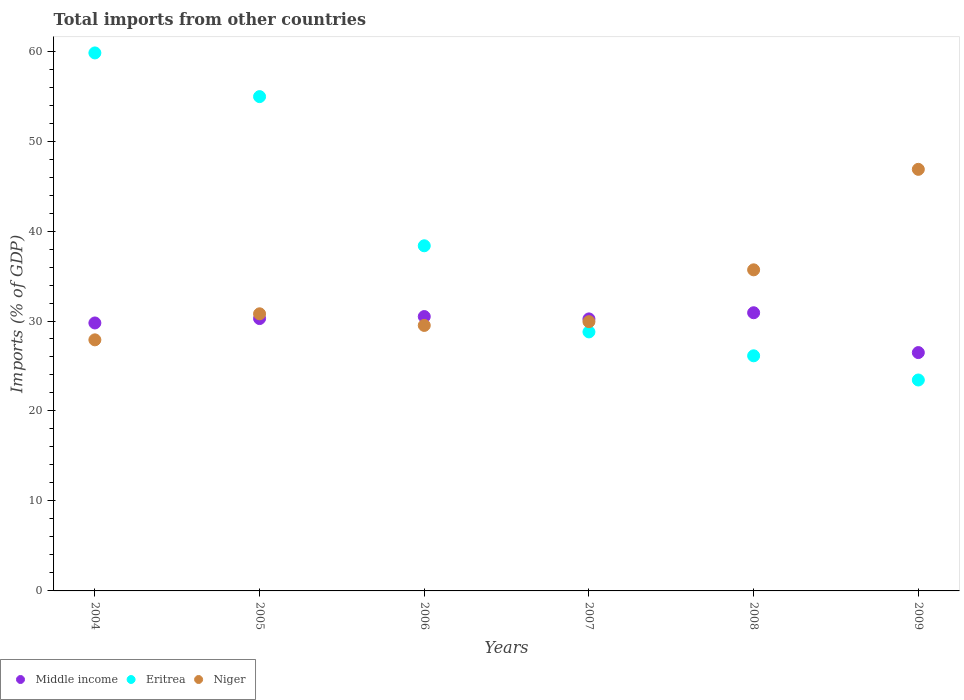How many different coloured dotlines are there?
Give a very brief answer. 3. Is the number of dotlines equal to the number of legend labels?
Make the answer very short. Yes. What is the total imports in Middle income in 2005?
Keep it short and to the point. 30.27. Across all years, what is the maximum total imports in Eritrea?
Your response must be concise. 59.8. Across all years, what is the minimum total imports in Middle income?
Keep it short and to the point. 26.49. In which year was the total imports in Middle income maximum?
Provide a short and direct response. 2008. What is the total total imports in Eritrea in the graph?
Provide a short and direct response. 231.46. What is the difference between the total imports in Eritrea in 2004 and that in 2006?
Ensure brevity in your answer.  21.43. What is the difference between the total imports in Niger in 2008 and the total imports in Middle income in 2009?
Give a very brief answer. 9.2. What is the average total imports in Niger per year?
Provide a succinct answer. 33.45. In the year 2007, what is the difference between the total imports in Eritrea and total imports in Niger?
Your answer should be compact. -1.14. What is the ratio of the total imports in Eritrea in 2004 to that in 2007?
Your answer should be very brief. 2.08. Is the total imports in Eritrea in 2004 less than that in 2005?
Give a very brief answer. No. Is the difference between the total imports in Eritrea in 2005 and 2007 greater than the difference between the total imports in Niger in 2005 and 2007?
Your answer should be compact. Yes. What is the difference between the highest and the second highest total imports in Niger?
Make the answer very short. 11.17. What is the difference between the highest and the lowest total imports in Middle income?
Ensure brevity in your answer.  4.43. Is the sum of the total imports in Eritrea in 2004 and 2009 greater than the maximum total imports in Niger across all years?
Ensure brevity in your answer.  Yes. Is the total imports in Middle income strictly greater than the total imports in Eritrea over the years?
Your answer should be compact. No. How many years are there in the graph?
Your answer should be compact. 6. Are the values on the major ticks of Y-axis written in scientific E-notation?
Your response must be concise. No. Does the graph contain grids?
Provide a succinct answer. No. How many legend labels are there?
Your answer should be compact. 3. What is the title of the graph?
Offer a terse response. Total imports from other countries. What is the label or title of the Y-axis?
Keep it short and to the point. Imports (% of GDP). What is the Imports (% of GDP) of Middle income in 2004?
Give a very brief answer. 29.78. What is the Imports (% of GDP) of Eritrea in 2004?
Offer a very short reply. 59.8. What is the Imports (% of GDP) of Niger in 2004?
Make the answer very short. 27.91. What is the Imports (% of GDP) of Middle income in 2005?
Make the answer very short. 30.27. What is the Imports (% of GDP) in Eritrea in 2005?
Give a very brief answer. 54.94. What is the Imports (% of GDP) in Niger in 2005?
Keep it short and to the point. 30.8. What is the Imports (% of GDP) in Middle income in 2006?
Provide a short and direct response. 30.49. What is the Imports (% of GDP) in Eritrea in 2006?
Provide a short and direct response. 38.36. What is the Imports (% of GDP) in Niger in 2006?
Give a very brief answer. 29.51. What is the Imports (% of GDP) in Middle income in 2007?
Provide a succinct answer. 30.23. What is the Imports (% of GDP) of Eritrea in 2007?
Your answer should be compact. 28.79. What is the Imports (% of GDP) in Niger in 2007?
Keep it short and to the point. 29.93. What is the Imports (% of GDP) of Middle income in 2008?
Keep it short and to the point. 30.92. What is the Imports (% of GDP) of Eritrea in 2008?
Your response must be concise. 26.13. What is the Imports (% of GDP) in Niger in 2008?
Your response must be concise. 35.69. What is the Imports (% of GDP) in Middle income in 2009?
Make the answer very short. 26.49. What is the Imports (% of GDP) of Eritrea in 2009?
Keep it short and to the point. 23.44. What is the Imports (% of GDP) in Niger in 2009?
Your response must be concise. 46.86. Across all years, what is the maximum Imports (% of GDP) in Middle income?
Provide a short and direct response. 30.92. Across all years, what is the maximum Imports (% of GDP) in Eritrea?
Offer a terse response. 59.8. Across all years, what is the maximum Imports (% of GDP) of Niger?
Provide a short and direct response. 46.86. Across all years, what is the minimum Imports (% of GDP) of Middle income?
Provide a succinct answer. 26.49. Across all years, what is the minimum Imports (% of GDP) of Eritrea?
Provide a short and direct response. 23.44. Across all years, what is the minimum Imports (% of GDP) in Niger?
Keep it short and to the point. 27.91. What is the total Imports (% of GDP) of Middle income in the graph?
Offer a terse response. 178.19. What is the total Imports (% of GDP) of Eritrea in the graph?
Keep it short and to the point. 231.46. What is the total Imports (% of GDP) in Niger in the graph?
Make the answer very short. 200.69. What is the difference between the Imports (% of GDP) in Middle income in 2004 and that in 2005?
Your answer should be compact. -0.49. What is the difference between the Imports (% of GDP) of Eritrea in 2004 and that in 2005?
Offer a terse response. 4.86. What is the difference between the Imports (% of GDP) of Niger in 2004 and that in 2005?
Keep it short and to the point. -2.89. What is the difference between the Imports (% of GDP) of Middle income in 2004 and that in 2006?
Ensure brevity in your answer.  -0.71. What is the difference between the Imports (% of GDP) in Eritrea in 2004 and that in 2006?
Make the answer very short. 21.43. What is the difference between the Imports (% of GDP) of Niger in 2004 and that in 2006?
Your answer should be very brief. -1.6. What is the difference between the Imports (% of GDP) in Middle income in 2004 and that in 2007?
Your answer should be very brief. -0.45. What is the difference between the Imports (% of GDP) of Eritrea in 2004 and that in 2007?
Keep it short and to the point. 31.01. What is the difference between the Imports (% of GDP) in Niger in 2004 and that in 2007?
Provide a succinct answer. -2.02. What is the difference between the Imports (% of GDP) of Middle income in 2004 and that in 2008?
Offer a very short reply. -1.14. What is the difference between the Imports (% of GDP) of Eritrea in 2004 and that in 2008?
Keep it short and to the point. 33.66. What is the difference between the Imports (% of GDP) in Niger in 2004 and that in 2008?
Provide a short and direct response. -7.78. What is the difference between the Imports (% of GDP) of Middle income in 2004 and that in 2009?
Offer a very short reply. 3.29. What is the difference between the Imports (% of GDP) in Eritrea in 2004 and that in 2009?
Provide a short and direct response. 36.35. What is the difference between the Imports (% of GDP) in Niger in 2004 and that in 2009?
Keep it short and to the point. -18.95. What is the difference between the Imports (% of GDP) of Middle income in 2005 and that in 2006?
Make the answer very short. -0.22. What is the difference between the Imports (% of GDP) in Eritrea in 2005 and that in 2006?
Your response must be concise. 16.58. What is the difference between the Imports (% of GDP) in Niger in 2005 and that in 2006?
Your answer should be compact. 1.29. What is the difference between the Imports (% of GDP) in Middle income in 2005 and that in 2007?
Provide a succinct answer. 0.04. What is the difference between the Imports (% of GDP) in Eritrea in 2005 and that in 2007?
Your answer should be compact. 26.15. What is the difference between the Imports (% of GDP) of Niger in 2005 and that in 2007?
Provide a succinct answer. 0.87. What is the difference between the Imports (% of GDP) of Middle income in 2005 and that in 2008?
Provide a short and direct response. -0.65. What is the difference between the Imports (% of GDP) of Eritrea in 2005 and that in 2008?
Offer a very short reply. 28.81. What is the difference between the Imports (% of GDP) of Niger in 2005 and that in 2008?
Keep it short and to the point. -4.89. What is the difference between the Imports (% of GDP) in Middle income in 2005 and that in 2009?
Your answer should be compact. 3.78. What is the difference between the Imports (% of GDP) in Eritrea in 2005 and that in 2009?
Keep it short and to the point. 31.5. What is the difference between the Imports (% of GDP) in Niger in 2005 and that in 2009?
Provide a succinct answer. -16.06. What is the difference between the Imports (% of GDP) of Middle income in 2006 and that in 2007?
Your answer should be very brief. 0.26. What is the difference between the Imports (% of GDP) of Eritrea in 2006 and that in 2007?
Provide a succinct answer. 9.57. What is the difference between the Imports (% of GDP) in Niger in 2006 and that in 2007?
Ensure brevity in your answer.  -0.42. What is the difference between the Imports (% of GDP) of Middle income in 2006 and that in 2008?
Provide a short and direct response. -0.42. What is the difference between the Imports (% of GDP) of Eritrea in 2006 and that in 2008?
Offer a terse response. 12.23. What is the difference between the Imports (% of GDP) of Niger in 2006 and that in 2008?
Offer a very short reply. -6.18. What is the difference between the Imports (% of GDP) of Middle income in 2006 and that in 2009?
Offer a very short reply. 4. What is the difference between the Imports (% of GDP) in Eritrea in 2006 and that in 2009?
Your answer should be very brief. 14.92. What is the difference between the Imports (% of GDP) of Niger in 2006 and that in 2009?
Your answer should be compact. -17.35. What is the difference between the Imports (% of GDP) in Middle income in 2007 and that in 2008?
Your response must be concise. -0.68. What is the difference between the Imports (% of GDP) of Eritrea in 2007 and that in 2008?
Provide a succinct answer. 2.66. What is the difference between the Imports (% of GDP) in Niger in 2007 and that in 2008?
Make the answer very short. -5.76. What is the difference between the Imports (% of GDP) of Middle income in 2007 and that in 2009?
Your answer should be very brief. 3.74. What is the difference between the Imports (% of GDP) of Eritrea in 2007 and that in 2009?
Ensure brevity in your answer.  5.34. What is the difference between the Imports (% of GDP) of Niger in 2007 and that in 2009?
Ensure brevity in your answer.  -16.93. What is the difference between the Imports (% of GDP) of Middle income in 2008 and that in 2009?
Keep it short and to the point. 4.43. What is the difference between the Imports (% of GDP) of Eritrea in 2008 and that in 2009?
Provide a short and direct response. 2.69. What is the difference between the Imports (% of GDP) of Niger in 2008 and that in 2009?
Keep it short and to the point. -11.17. What is the difference between the Imports (% of GDP) in Middle income in 2004 and the Imports (% of GDP) in Eritrea in 2005?
Give a very brief answer. -25.16. What is the difference between the Imports (% of GDP) in Middle income in 2004 and the Imports (% of GDP) in Niger in 2005?
Keep it short and to the point. -1.02. What is the difference between the Imports (% of GDP) of Eritrea in 2004 and the Imports (% of GDP) of Niger in 2005?
Make the answer very short. 29. What is the difference between the Imports (% of GDP) of Middle income in 2004 and the Imports (% of GDP) of Eritrea in 2006?
Offer a terse response. -8.58. What is the difference between the Imports (% of GDP) of Middle income in 2004 and the Imports (% of GDP) of Niger in 2006?
Keep it short and to the point. 0.27. What is the difference between the Imports (% of GDP) in Eritrea in 2004 and the Imports (% of GDP) in Niger in 2006?
Keep it short and to the point. 30.29. What is the difference between the Imports (% of GDP) in Middle income in 2004 and the Imports (% of GDP) in Eritrea in 2007?
Your answer should be compact. 0.99. What is the difference between the Imports (% of GDP) in Middle income in 2004 and the Imports (% of GDP) in Niger in 2007?
Your answer should be compact. -0.14. What is the difference between the Imports (% of GDP) in Eritrea in 2004 and the Imports (% of GDP) in Niger in 2007?
Your response must be concise. 29.87. What is the difference between the Imports (% of GDP) of Middle income in 2004 and the Imports (% of GDP) of Eritrea in 2008?
Your answer should be very brief. 3.65. What is the difference between the Imports (% of GDP) in Middle income in 2004 and the Imports (% of GDP) in Niger in 2008?
Ensure brevity in your answer.  -5.91. What is the difference between the Imports (% of GDP) in Eritrea in 2004 and the Imports (% of GDP) in Niger in 2008?
Provide a short and direct response. 24.11. What is the difference between the Imports (% of GDP) in Middle income in 2004 and the Imports (% of GDP) in Eritrea in 2009?
Your response must be concise. 6.34. What is the difference between the Imports (% of GDP) of Middle income in 2004 and the Imports (% of GDP) of Niger in 2009?
Make the answer very short. -17.07. What is the difference between the Imports (% of GDP) in Eritrea in 2004 and the Imports (% of GDP) in Niger in 2009?
Ensure brevity in your answer.  12.94. What is the difference between the Imports (% of GDP) in Middle income in 2005 and the Imports (% of GDP) in Eritrea in 2006?
Ensure brevity in your answer.  -8.09. What is the difference between the Imports (% of GDP) in Middle income in 2005 and the Imports (% of GDP) in Niger in 2006?
Your answer should be very brief. 0.76. What is the difference between the Imports (% of GDP) in Eritrea in 2005 and the Imports (% of GDP) in Niger in 2006?
Offer a very short reply. 25.43. What is the difference between the Imports (% of GDP) of Middle income in 2005 and the Imports (% of GDP) of Eritrea in 2007?
Provide a succinct answer. 1.48. What is the difference between the Imports (% of GDP) in Middle income in 2005 and the Imports (% of GDP) in Niger in 2007?
Your answer should be very brief. 0.34. What is the difference between the Imports (% of GDP) in Eritrea in 2005 and the Imports (% of GDP) in Niger in 2007?
Your answer should be compact. 25.01. What is the difference between the Imports (% of GDP) in Middle income in 2005 and the Imports (% of GDP) in Eritrea in 2008?
Offer a very short reply. 4.14. What is the difference between the Imports (% of GDP) in Middle income in 2005 and the Imports (% of GDP) in Niger in 2008?
Provide a succinct answer. -5.42. What is the difference between the Imports (% of GDP) in Eritrea in 2005 and the Imports (% of GDP) in Niger in 2008?
Provide a succinct answer. 19.25. What is the difference between the Imports (% of GDP) of Middle income in 2005 and the Imports (% of GDP) of Eritrea in 2009?
Offer a terse response. 6.83. What is the difference between the Imports (% of GDP) in Middle income in 2005 and the Imports (% of GDP) in Niger in 2009?
Ensure brevity in your answer.  -16.59. What is the difference between the Imports (% of GDP) of Eritrea in 2005 and the Imports (% of GDP) of Niger in 2009?
Offer a terse response. 8.08. What is the difference between the Imports (% of GDP) of Middle income in 2006 and the Imports (% of GDP) of Eritrea in 2007?
Give a very brief answer. 1.71. What is the difference between the Imports (% of GDP) in Middle income in 2006 and the Imports (% of GDP) in Niger in 2007?
Keep it short and to the point. 0.57. What is the difference between the Imports (% of GDP) of Eritrea in 2006 and the Imports (% of GDP) of Niger in 2007?
Offer a very short reply. 8.44. What is the difference between the Imports (% of GDP) in Middle income in 2006 and the Imports (% of GDP) in Eritrea in 2008?
Offer a terse response. 4.36. What is the difference between the Imports (% of GDP) of Middle income in 2006 and the Imports (% of GDP) of Niger in 2008?
Provide a succinct answer. -5.19. What is the difference between the Imports (% of GDP) of Eritrea in 2006 and the Imports (% of GDP) of Niger in 2008?
Give a very brief answer. 2.67. What is the difference between the Imports (% of GDP) of Middle income in 2006 and the Imports (% of GDP) of Eritrea in 2009?
Keep it short and to the point. 7.05. What is the difference between the Imports (% of GDP) in Middle income in 2006 and the Imports (% of GDP) in Niger in 2009?
Keep it short and to the point. -16.36. What is the difference between the Imports (% of GDP) of Eritrea in 2006 and the Imports (% of GDP) of Niger in 2009?
Make the answer very short. -8.5. What is the difference between the Imports (% of GDP) of Middle income in 2007 and the Imports (% of GDP) of Eritrea in 2008?
Make the answer very short. 4.1. What is the difference between the Imports (% of GDP) of Middle income in 2007 and the Imports (% of GDP) of Niger in 2008?
Make the answer very short. -5.45. What is the difference between the Imports (% of GDP) of Eritrea in 2007 and the Imports (% of GDP) of Niger in 2008?
Your response must be concise. -6.9. What is the difference between the Imports (% of GDP) in Middle income in 2007 and the Imports (% of GDP) in Eritrea in 2009?
Your answer should be compact. 6.79. What is the difference between the Imports (% of GDP) of Middle income in 2007 and the Imports (% of GDP) of Niger in 2009?
Make the answer very short. -16.62. What is the difference between the Imports (% of GDP) of Eritrea in 2007 and the Imports (% of GDP) of Niger in 2009?
Your answer should be very brief. -18.07. What is the difference between the Imports (% of GDP) in Middle income in 2008 and the Imports (% of GDP) in Eritrea in 2009?
Keep it short and to the point. 7.47. What is the difference between the Imports (% of GDP) of Middle income in 2008 and the Imports (% of GDP) of Niger in 2009?
Make the answer very short. -15.94. What is the difference between the Imports (% of GDP) of Eritrea in 2008 and the Imports (% of GDP) of Niger in 2009?
Ensure brevity in your answer.  -20.72. What is the average Imports (% of GDP) in Middle income per year?
Make the answer very short. 29.7. What is the average Imports (% of GDP) in Eritrea per year?
Provide a short and direct response. 38.58. What is the average Imports (% of GDP) in Niger per year?
Your answer should be very brief. 33.45. In the year 2004, what is the difference between the Imports (% of GDP) in Middle income and Imports (% of GDP) in Eritrea?
Make the answer very short. -30.01. In the year 2004, what is the difference between the Imports (% of GDP) of Middle income and Imports (% of GDP) of Niger?
Ensure brevity in your answer.  1.88. In the year 2004, what is the difference between the Imports (% of GDP) of Eritrea and Imports (% of GDP) of Niger?
Give a very brief answer. 31.89. In the year 2005, what is the difference between the Imports (% of GDP) in Middle income and Imports (% of GDP) in Eritrea?
Provide a succinct answer. -24.67. In the year 2005, what is the difference between the Imports (% of GDP) of Middle income and Imports (% of GDP) of Niger?
Ensure brevity in your answer.  -0.53. In the year 2005, what is the difference between the Imports (% of GDP) of Eritrea and Imports (% of GDP) of Niger?
Offer a very short reply. 24.14. In the year 2006, what is the difference between the Imports (% of GDP) in Middle income and Imports (% of GDP) in Eritrea?
Your response must be concise. -7.87. In the year 2006, what is the difference between the Imports (% of GDP) in Middle income and Imports (% of GDP) in Niger?
Provide a succinct answer. 0.98. In the year 2006, what is the difference between the Imports (% of GDP) of Eritrea and Imports (% of GDP) of Niger?
Your answer should be very brief. 8.85. In the year 2007, what is the difference between the Imports (% of GDP) in Middle income and Imports (% of GDP) in Eritrea?
Offer a terse response. 1.45. In the year 2007, what is the difference between the Imports (% of GDP) of Middle income and Imports (% of GDP) of Niger?
Offer a terse response. 0.31. In the year 2007, what is the difference between the Imports (% of GDP) of Eritrea and Imports (% of GDP) of Niger?
Make the answer very short. -1.14. In the year 2008, what is the difference between the Imports (% of GDP) in Middle income and Imports (% of GDP) in Eritrea?
Provide a succinct answer. 4.79. In the year 2008, what is the difference between the Imports (% of GDP) of Middle income and Imports (% of GDP) of Niger?
Provide a short and direct response. -4.77. In the year 2008, what is the difference between the Imports (% of GDP) of Eritrea and Imports (% of GDP) of Niger?
Offer a terse response. -9.56. In the year 2009, what is the difference between the Imports (% of GDP) of Middle income and Imports (% of GDP) of Eritrea?
Ensure brevity in your answer.  3.05. In the year 2009, what is the difference between the Imports (% of GDP) of Middle income and Imports (% of GDP) of Niger?
Give a very brief answer. -20.37. In the year 2009, what is the difference between the Imports (% of GDP) in Eritrea and Imports (% of GDP) in Niger?
Your response must be concise. -23.41. What is the ratio of the Imports (% of GDP) of Middle income in 2004 to that in 2005?
Provide a succinct answer. 0.98. What is the ratio of the Imports (% of GDP) of Eritrea in 2004 to that in 2005?
Offer a terse response. 1.09. What is the ratio of the Imports (% of GDP) in Niger in 2004 to that in 2005?
Provide a succinct answer. 0.91. What is the ratio of the Imports (% of GDP) in Middle income in 2004 to that in 2006?
Provide a succinct answer. 0.98. What is the ratio of the Imports (% of GDP) in Eritrea in 2004 to that in 2006?
Your response must be concise. 1.56. What is the ratio of the Imports (% of GDP) of Niger in 2004 to that in 2006?
Provide a succinct answer. 0.95. What is the ratio of the Imports (% of GDP) of Middle income in 2004 to that in 2007?
Your response must be concise. 0.99. What is the ratio of the Imports (% of GDP) in Eritrea in 2004 to that in 2007?
Offer a very short reply. 2.08. What is the ratio of the Imports (% of GDP) of Niger in 2004 to that in 2007?
Your answer should be very brief. 0.93. What is the ratio of the Imports (% of GDP) in Middle income in 2004 to that in 2008?
Offer a terse response. 0.96. What is the ratio of the Imports (% of GDP) of Eritrea in 2004 to that in 2008?
Keep it short and to the point. 2.29. What is the ratio of the Imports (% of GDP) in Niger in 2004 to that in 2008?
Ensure brevity in your answer.  0.78. What is the ratio of the Imports (% of GDP) of Middle income in 2004 to that in 2009?
Your answer should be compact. 1.12. What is the ratio of the Imports (% of GDP) of Eritrea in 2004 to that in 2009?
Offer a very short reply. 2.55. What is the ratio of the Imports (% of GDP) of Niger in 2004 to that in 2009?
Offer a very short reply. 0.6. What is the ratio of the Imports (% of GDP) in Middle income in 2005 to that in 2006?
Your answer should be very brief. 0.99. What is the ratio of the Imports (% of GDP) of Eritrea in 2005 to that in 2006?
Your response must be concise. 1.43. What is the ratio of the Imports (% of GDP) of Niger in 2005 to that in 2006?
Your response must be concise. 1.04. What is the ratio of the Imports (% of GDP) in Eritrea in 2005 to that in 2007?
Provide a short and direct response. 1.91. What is the ratio of the Imports (% of GDP) in Niger in 2005 to that in 2007?
Provide a short and direct response. 1.03. What is the ratio of the Imports (% of GDP) of Middle income in 2005 to that in 2008?
Your answer should be very brief. 0.98. What is the ratio of the Imports (% of GDP) of Eritrea in 2005 to that in 2008?
Make the answer very short. 2.1. What is the ratio of the Imports (% of GDP) in Niger in 2005 to that in 2008?
Provide a succinct answer. 0.86. What is the ratio of the Imports (% of GDP) in Middle income in 2005 to that in 2009?
Make the answer very short. 1.14. What is the ratio of the Imports (% of GDP) of Eritrea in 2005 to that in 2009?
Your answer should be compact. 2.34. What is the ratio of the Imports (% of GDP) in Niger in 2005 to that in 2009?
Offer a very short reply. 0.66. What is the ratio of the Imports (% of GDP) in Middle income in 2006 to that in 2007?
Provide a succinct answer. 1.01. What is the ratio of the Imports (% of GDP) in Eritrea in 2006 to that in 2007?
Make the answer very short. 1.33. What is the ratio of the Imports (% of GDP) of Niger in 2006 to that in 2007?
Give a very brief answer. 0.99. What is the ratio of the Imports (% of GDP) of Middle income in 2006 to that in 2008?
Provide a short and direct response. 0.99. What is the ratio of the Imports (% of GDP) of Eritrea in 2006 to that in 2008?
Make the answer very short. 1.47. What is the ratio of the Imports (% of GDP) of Niger in 2006 to that in 2008?
Give a very brief answer. 0.83. What is the ratio of the Imports (% of GDP) of Middle income in 2006 to that in 2009?
Your answer should be very brief. 1.15. What is the ratio of the Imports (% of GDP) of Eritrea in 2006 to that in 2009?
Ensure brevity in your answer.  1.64. What is the ratio of the Imports (% of GDP) in Niger in 2006 to that in 2009?
Make the answer very short. 0.63. What is the ratio of the Imports (% of GDP) of Middle income in 2007 to that in 2008?
Offer a terse response. 0.98. What is the ratio of the Imports (% of GDP) in Eritrea in 2007 to that in 2008?
Ensure brevity in your answer.  1.1. What is the ratio of the Imports (% of GDP) in Niger in 2007 to that in 2008?
Give a very brief answer. 0.84. What is the ratio of the Imports (% of GDP) of Middle income in 2007 to that in 2009?
Ensure brevity in your answer.  1.14. What is the ratio of the Imports (% of GDP) in Eritrea in 2007 to that in 2009?
Offer a terse response. 1.23. What is the ratio of the Imports (% of GDP) in Niger in 2007 to that in 2009?
Ensure brevity in your answer.  0.64. What is the ratio of the Imports (% of GDP) in Middle income in 2008 to that in 2009?
Your response must be concise. 1.17. What is the ratio of the Imports (% of GDP) of Eritrea in 2008 to that in 2009?
Your response must be concise. 1.11. What is the ratio of the Imports (% of GDP) in Niger in 2008 to that in 2009?
Provide a short and direct response. 0.76. What is the difference between the highest and the second highest Imports (% of GDP) in Middle income?
Provide a short and direct response. 0.42. What is the difference between the highest and the second highest Imports (% of GDP) in Eritrea?
Provide a short and direct response. 4.86. What is the difference between the highest and the second highest Imports (% of GDP) of Niger?
Make the answer very short. 11.17. What is the difference between the highest and the lowest Imports (% of GDP) of Middle income?
Provide a succinct answer. 4.43. What is the difference between the highest and the lowest Imports (% of GDP) of Eritrea?
Make the answer very short. 36.35. What is the difference between the highest and the lowest Imports (% of GDP) of Niger?
Give a very brief answer. 18.95. 